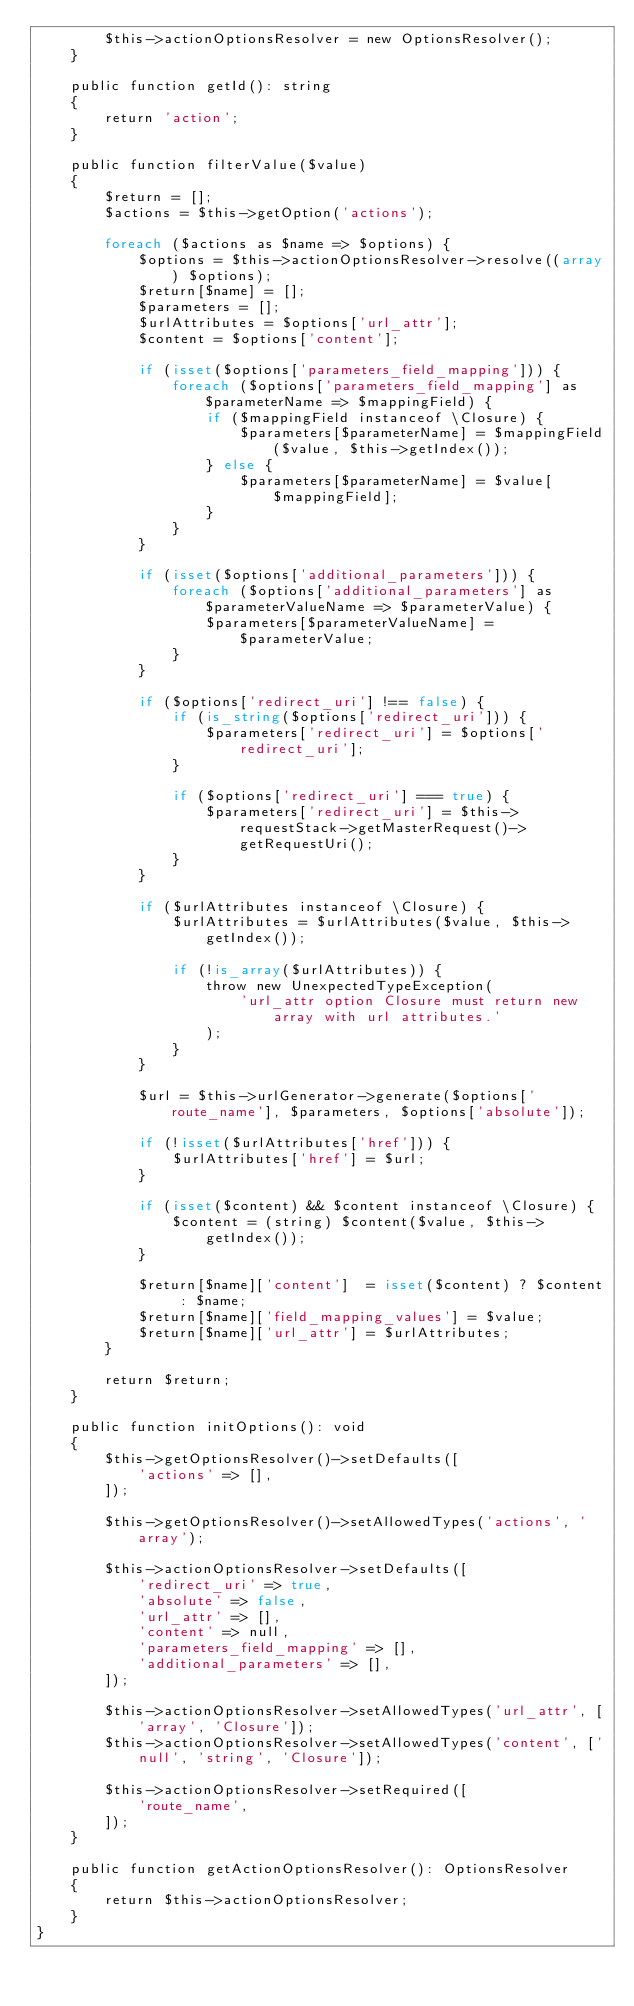<code> <loc_0><loc_0><loc_500><loc_500><_PHP_>        $this->actionOptionsResolver = new OptionsResolver();
    }

    public function getId(): string
    {
        return 'action';
    }

    public function filterValue($value)
    {
        $return = [];
        $actions = $this->getOption('actions');

        foreach ($actions as $name => $options) {
            $options = $this->actionOptionsResolver->resolve((array) $options);
            $return[$name] = [];
            $parameters = [];
            $urlAttributes = $options['url_attr'];
            $content = $options['content'];

            if (isset($options['parameters_field_mapping'])) {
                foreach ($options['parameters_field_mapping'] as $parameterName => $mappingField) {
                    if ($mappingField instanceof \Closure) {
                        $parameters[$parameterName] = $mappingField($value, $this->getIndex());
                    } else {
                        $parameters[$parameterName] = $value[$mappingField];
                    }
                }
            }

            if (isset($options['additional_parameters'])) {
                foreach ($options['additional_parameters'] as $parameterValueName => $parameterValue) {
                    $parameters[$parameterValueName] = $parameterValue;
                }
            }

            if ($options['redirect_uri'] !== false) {
                if (is_string($options['redirect_uri'])) {
                    $parameters['redirect_uri'] = $options['redirect_uri'];
                }

                if ($options['redirect_uri'] === true) {
                    $parameters['redirect_uri'] = $this->requestStack->getMasterRequest()->getRequestUri();
                }
            }

            if ($urlAttributes instanceof \Closure) {
                $urlAttributes = $urlAttributes($value, $this->getIndex());

                if (!is_array($urlAttributes)) {
                    throw new UnexpectedTypeException(
                        'url_attr option Closure must return new array with url attributes.'
                    );
                }
            }

            $url = $this->urlGenerator->generate($options['route_name'], $parameters, $options['absolute']);

            if (!isset($urlAttributes['href'])) {
                $urlAttributes['href'] = $url;
            }

            if (isset($content) && $content instanceof \Closure) {
                $content = (string) $content($value, $this->getIndex());
            }

            $return[$name]['content']  = isset($content) ? $content : $name;
            $return[$name]['field_mapping_values'] = $value;
            $return[$name]['url_attr'] = $urlAttributes;
        }

        return $return;
    }

    public function initOptions(): void
    {
        $this->getOptionsResolver()->setDefaults([
            'actions' => [],
        ]);

        $this->getOptionsResolver()->setAllowedTypes('actions', 'array');

        $this->actionOptionsResolver->setDefaults([
            'redirect_uri' => true,
            'absolute' => false,
            'url_attr' => [],
            'content' => null,
            'parameters_field_mapping' => [],
            'additional_parameters' => [],
        ]);

        $this->actionOptionsResolver->setAllowedTypes('url_attr', ['array', 'Closure']);
        $this->actionOptionsResolver->setAllowedTypes('content', ['null', 'string', 'Closure']);

        $this->actionOptionsResolver->setRequired([
            'route_name',
        ]);
    }

    public function getActionOptionsResolver(): OptionsResolver
    {
        return $this->actionOptionsResolver;
    }
}
</code> 